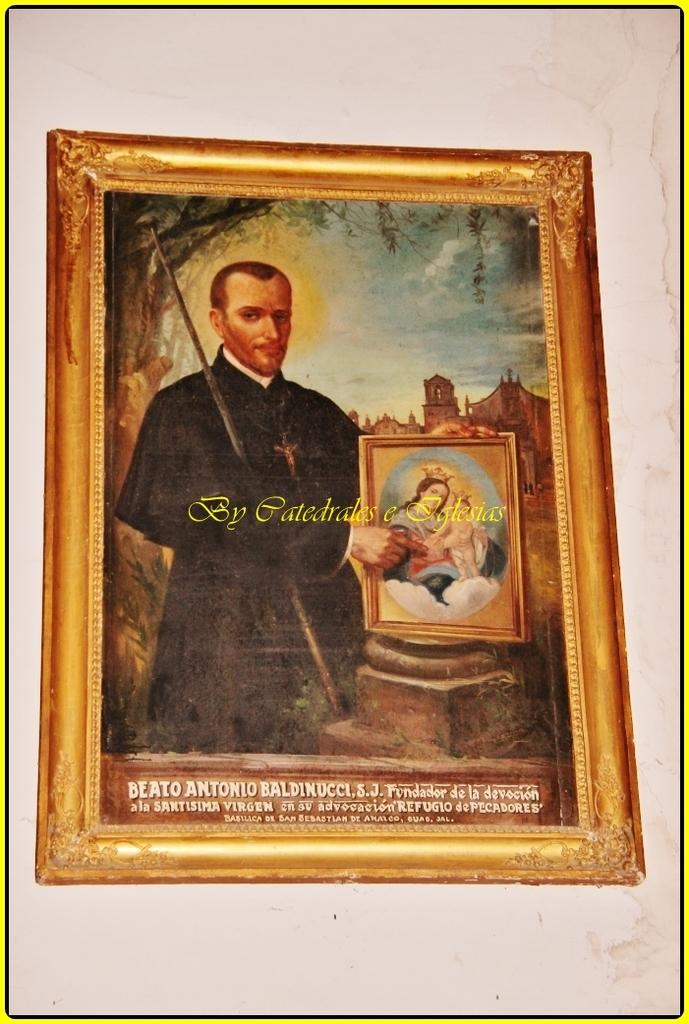<image>
Create a compact narrative representing the image presented. A framed picture of a man holding a framed picture of the Madonna and Child proclaims it is by Catedrales e Iglesias. 